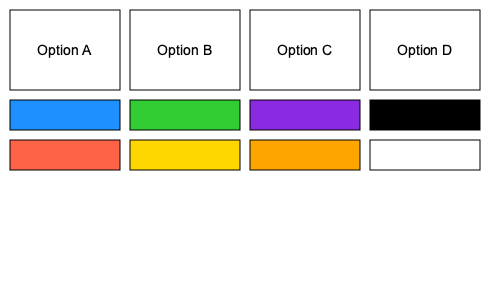Which color scheme option would be the most accessible for a React-based donation form, considering the needs of users with various visual impairments? To determine the most accessible color scheme for a React-based donation form, we need to consider the following factors:

1. Color contrast: The Web Content Accessibility Guidelines (WCAG) recommend a minimum contrast ratio of 4.5:1 for normal text and 3:1 for large text.

2. Color blindness: We should avoid color combinations that are difficult to distinguish for people with color vision deficiencies.

3. Simplicity: A simple color scheme with clear distinctions is easier for all users to navigate.

Let's analyze each option:

Option A: Blue (#1E90FF) and Red (#FF6347)
- Contrast ratio: Approximately 2.94:1 (fails WCAG guidelines)
- May be difficult for users with red-green color blindness

Option B: Green (#32CD32) and Yellow (#FFD700)
- Contrast ratio: Approximately 1.07:1 (fails WCAG guidelines)
- May be difficult for users with red-green color blindness

Option C: Purple (#8A2BE2) and Orange (#FFA500)
- Contrast ratio: Approximately 2.02:1 (fails WCAG guidelines)
- Better for color-blind users but still lacks sufficient contrast

Option D: Black (#000000) and White (#FFFFFF)
- Contrast ratio: 21:1 (exceeds WCAG guidelines)
- High contrast that works well for all types of color blindness
- Simple and clear distinction between elements

Based on this analysis, Option D (Black and White) provides the highest contrast ratio, works well for all types of color blindness, and offers a simple, clear distinction between elements. This makes it the most accessible choice for a wide range of users, including those with visual impairments.
Answer: Option D (Black and White) 